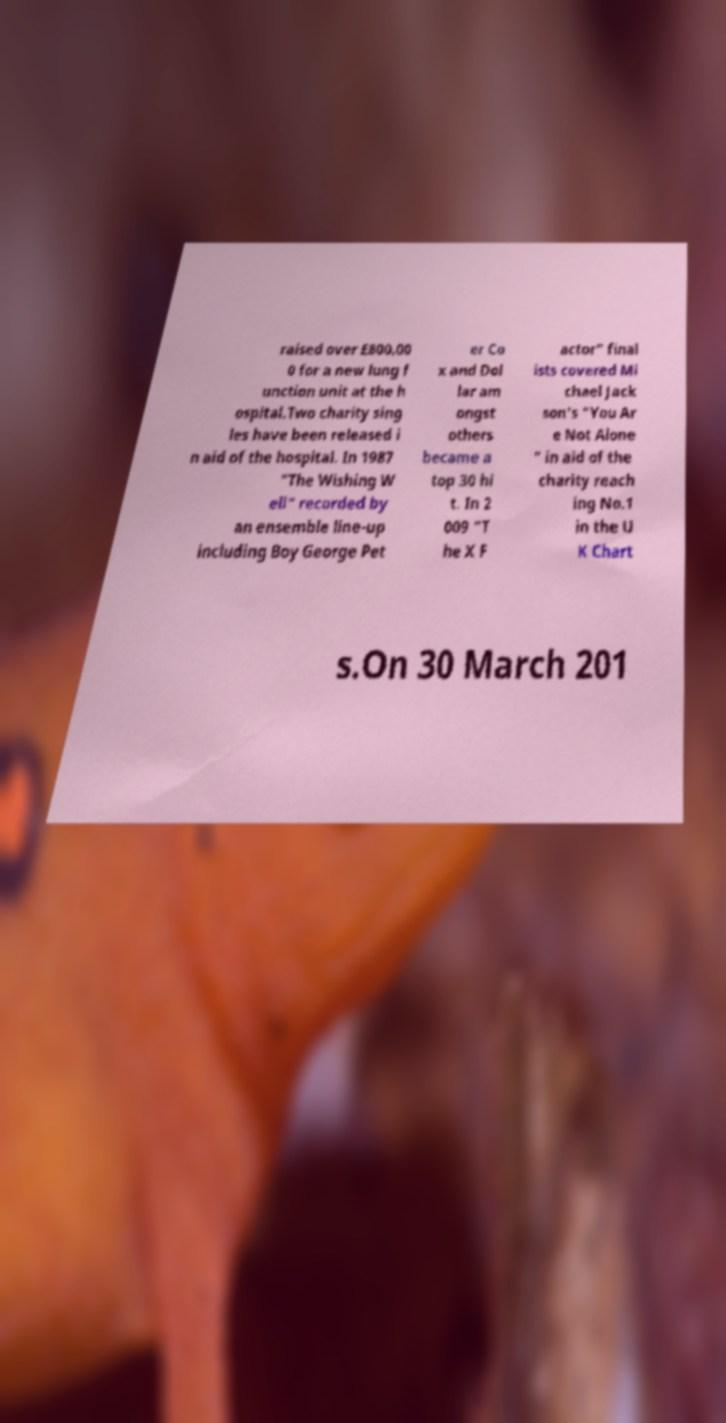I need the written content from this picture converted into text. Can you do that? raised over £800,00 0 for a new lung f unction unit at the h ospital.Two charity sing les have been released i n aid of the hospital. In 1987 "The Wishing W ell" recorded by an ensemble line-up including Boy George Pet er Co x and Dol lar am ongst others became a top 30 hi t. In 2 009 "T he X F actor" final ists covered Mi chael Jack son's "You Ar e Not Alone " in aid of the charity reach ing No.1 in the U K Chart s.On 30 March 201 